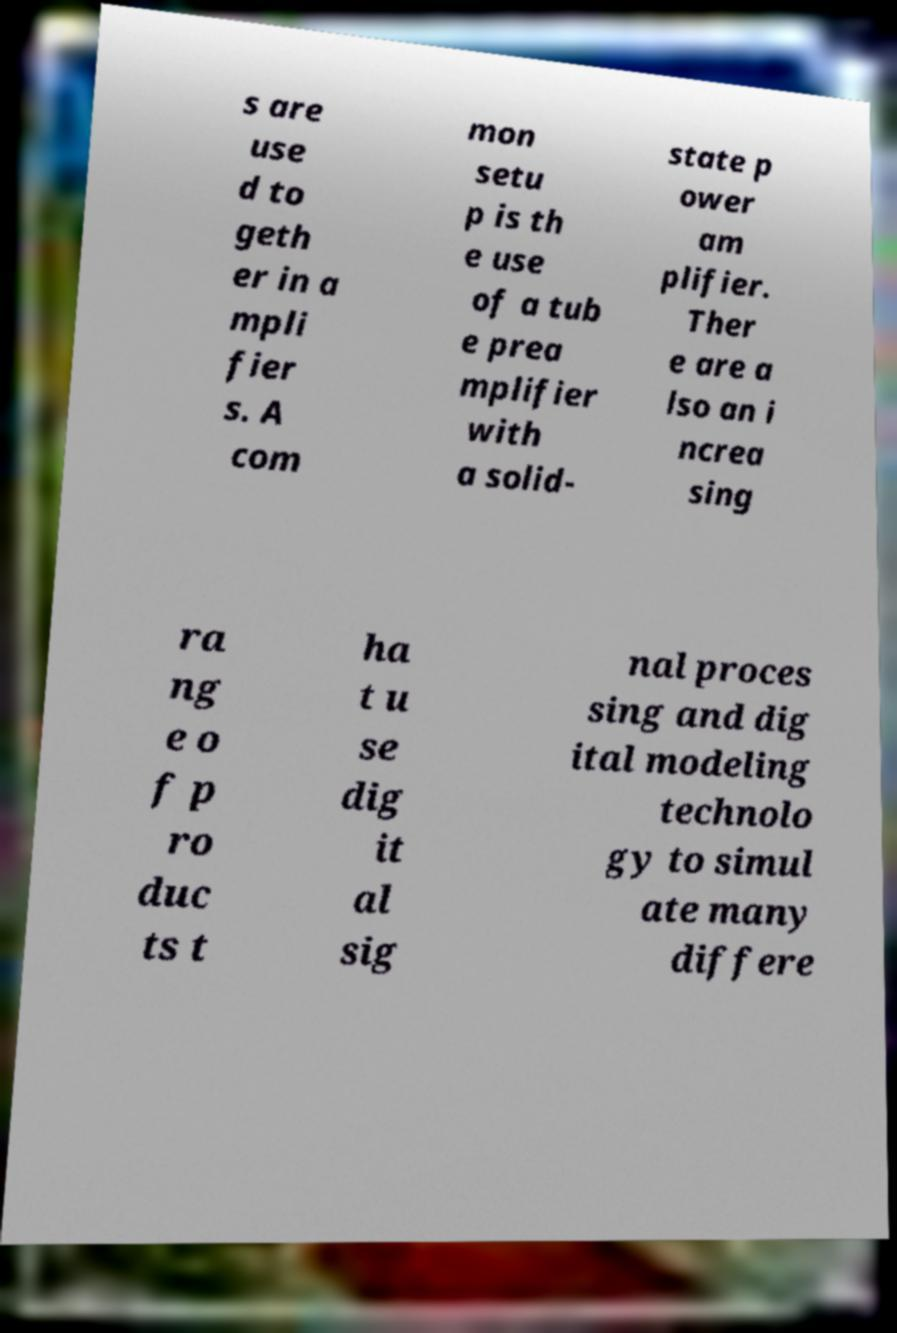Please identify and transcribe the text found in this image. s are use d to geth er in a mpli fier s. A com mon setu p is th e use of a tub e prea mplifier with a solid- state p ower am plifier. Ther e are a lso an i ncrea sing ra ng e o f p ro duc ts t ha t u se dig it al sig nal proces sing and dig ital modeling technolo gy to simul ate many differe 